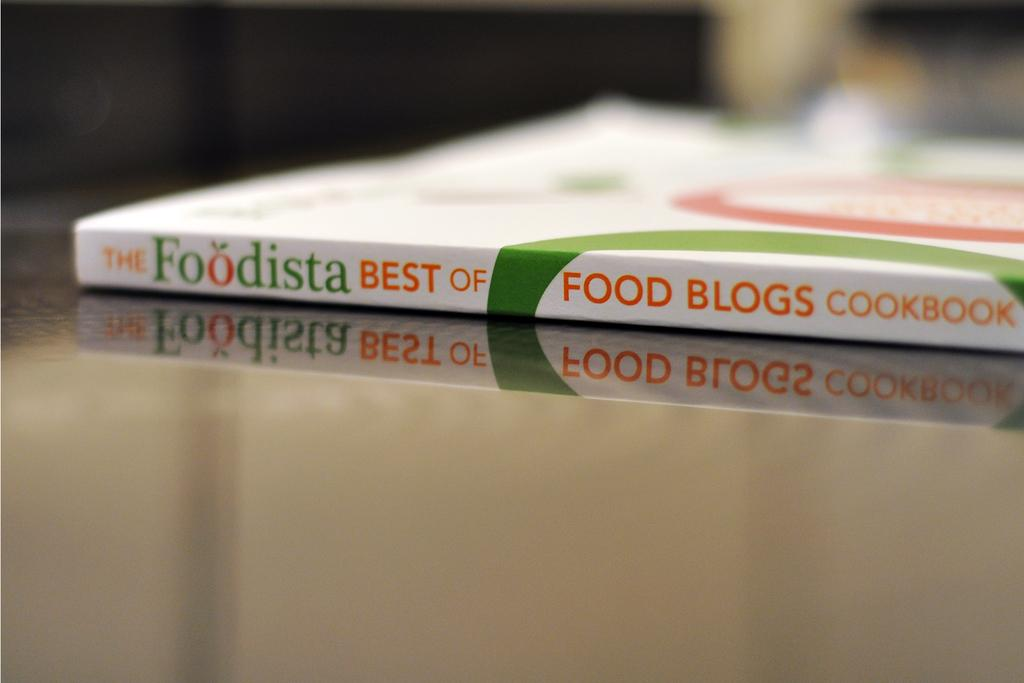<image>
Relay a brief, clear account of the picture shown. cookbook, the foodista best of food blogs laying on a shiny surface 